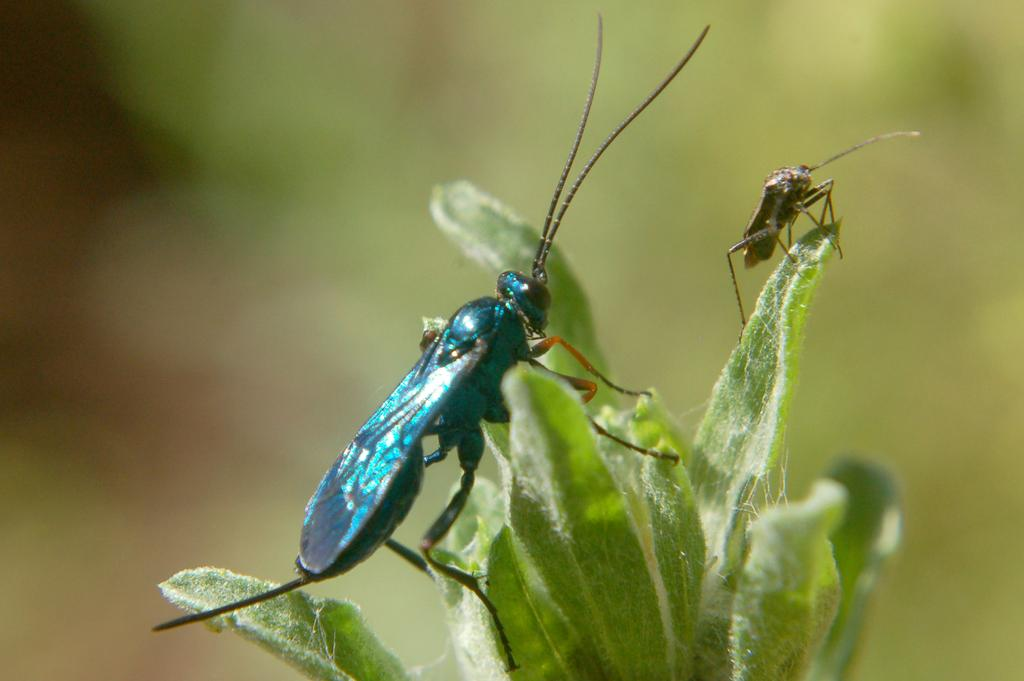What is present in the image? There are two insects in the image. Where are the insects located? The insects are on leaves. Can you describe the background of the image? The background of the image is blurred. What time of day is depicted in the image? The time of day is not depicted in the image, as there are no specific indicators of time. 